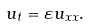Convert formula to latex. <formula><loc_0><loc_0><loc_500><loc_500>u _ { t } = \varepsilon u _ { x x } .</formula> 